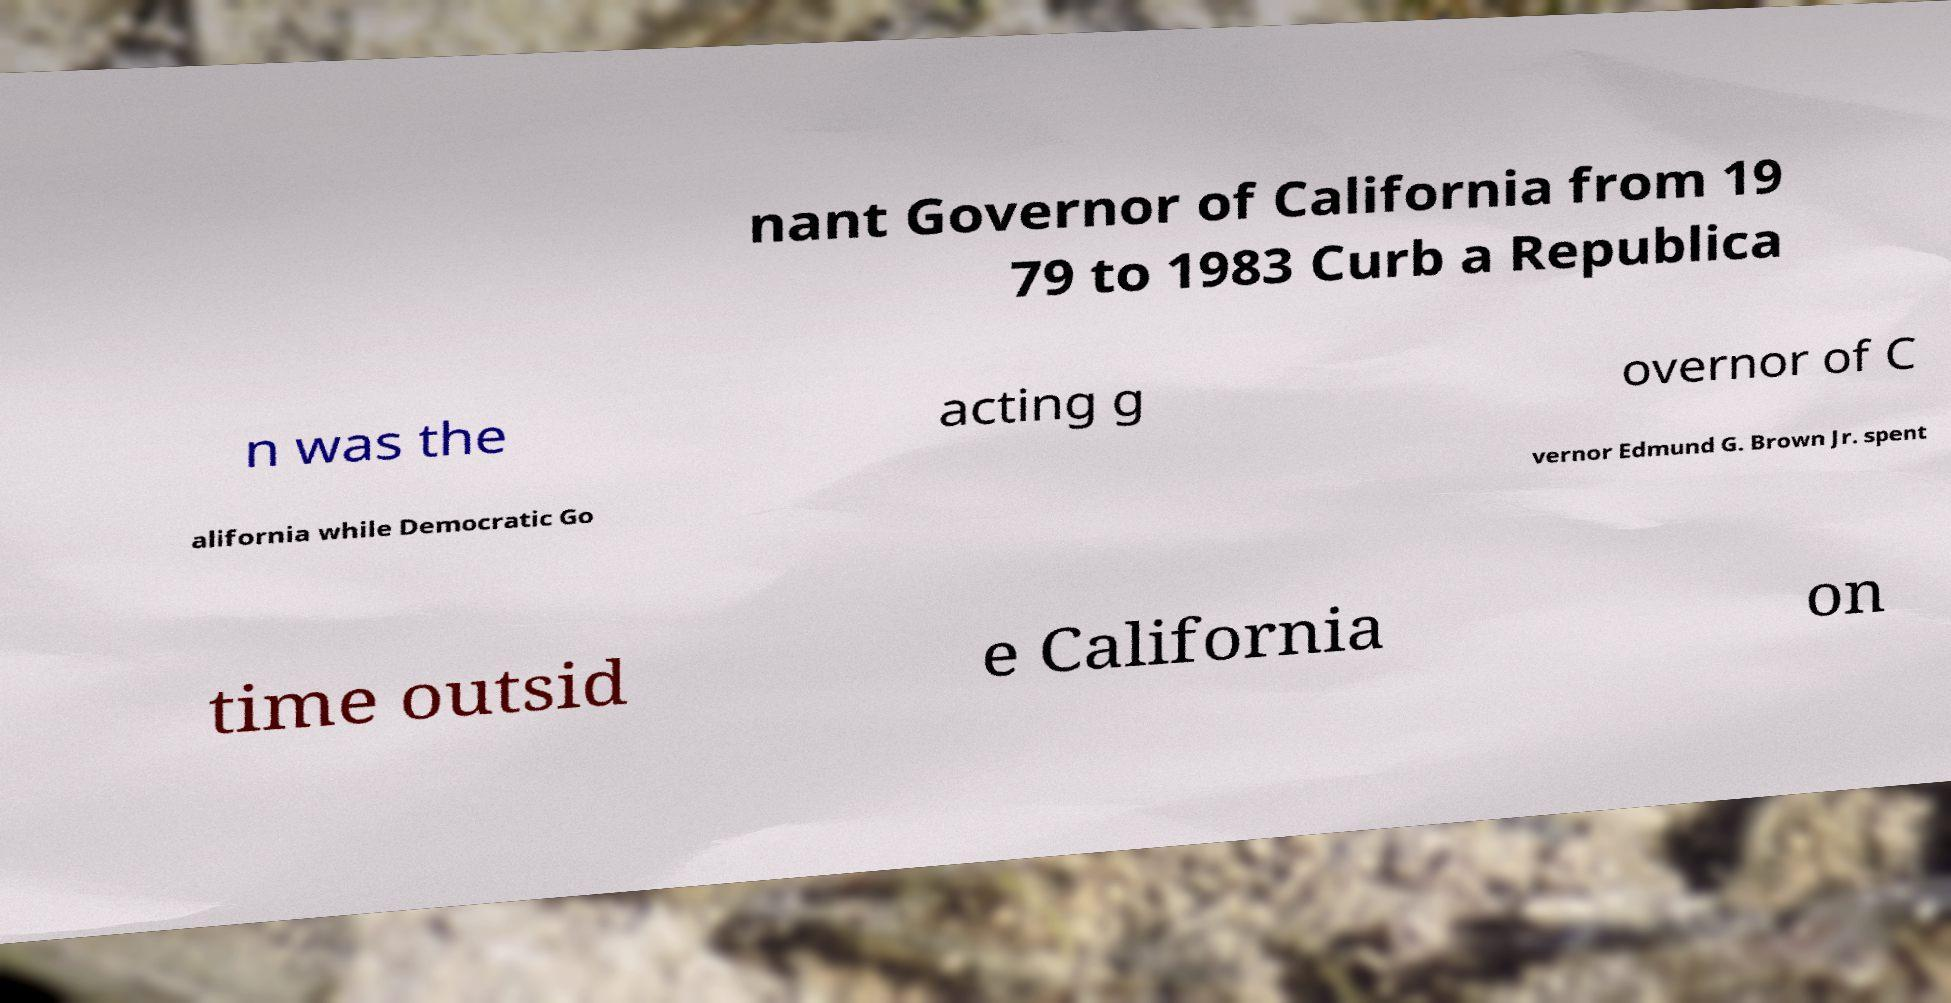Can you read and provide the text displayed in the image?This photo seems to have some interesting text. Can you extract and type it out for me? nant Governor of California from 19 79 to 1983 Curb a Republica n was the acting g overnor of C alifornia while Democratic Go vernor Edmund G. Brown Jr. spent time outsid e California on 